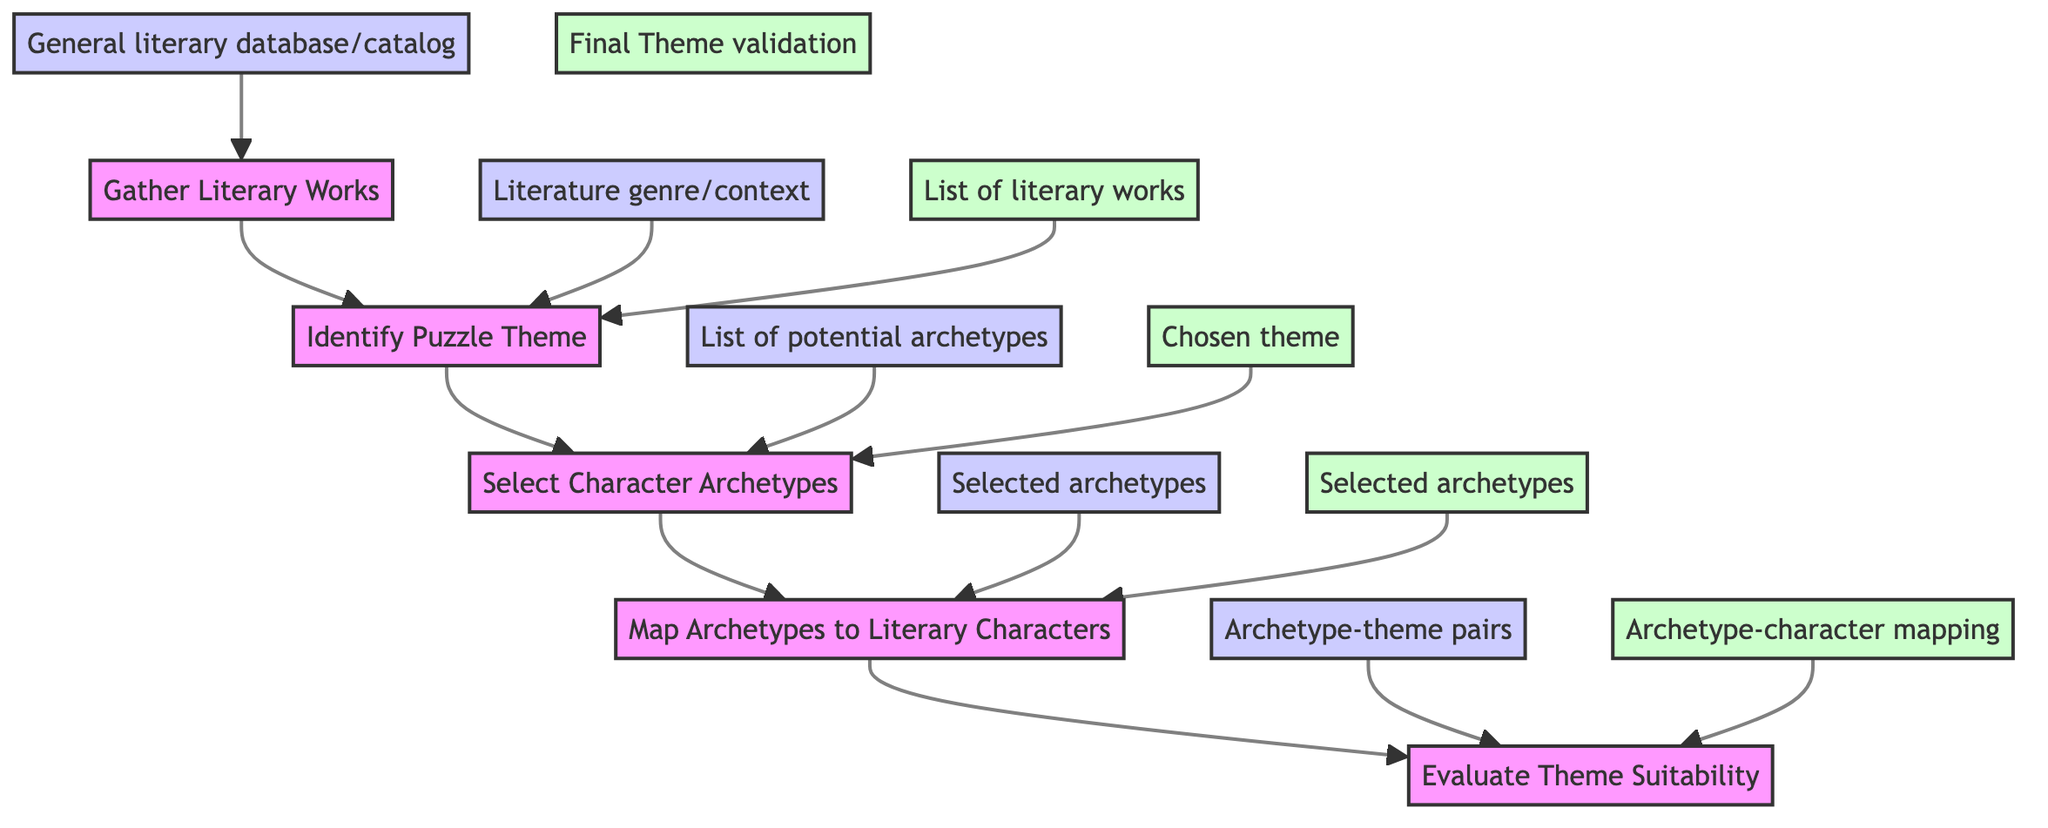What is the first step in the flowchart? The first step in the flowchart is to "Gather Literary Works," which is represented as node A. This is where diverse literary works are collected for analysis.
Answer: Gather Literary Works What is the output of the "Evaluate Theme Suitability" step? The output of the "Evaluate Theme Suitability" step, which is the final step E, is "Final Theme validation." This indicates that after assessing the archetypes' fit, the theme is validated.
Answer: Final Theme validation How many nodes are there in the flowchart? There are five nodes in the flowchart: "Gather Literary Works," "Identify Puzzle Theme," "Select Character Archetypes," "Map Archetypes to Literary Characters," and "Evaluate Theme Suitability." This includes both input and output nodes.
Answer: Five What input is needed for "Map Archetypes to Literary Characters"? The input needed for "Map Archetypes to Literary Characters," which is node D, is "Selected archetypes." These are the archetypes that have been chosen from earlier steps.
Answer: Selected archetypes Which step comes after "Select Character Archetypes"? The step that comes after "Select Character Archetypes," which is node C, is "Map Archetypes to Literary Characters," represented as node D. This indicates a sequential flow to identify characters corresponding to the archetypes.
Answer: Map Archetypes to Literary Characters What is the relationship between "Gather Literary Works" and "Identify Puzzle Theme"? The relationship between "Gather Literary Works" and "Identify Puzzle Theme" is that the output of "Gather Literary Works" serves as the input for "Identify Puzzle Theme." This means the collected works help define the puzzle theme.
Answer: Output serves as input What is the input for "Evaluate Theme Suitability"? The input for "Evaluate Theme Suitability," which is node E, is "Archetype-theme pairs." This indicates the specific data processed to validate the theme's appropriateness.
Answer: Archetype-theme pairs What type of data serves as an input for the "Gather Literary Works" step? The "Gather Literary Works" step requires input from a "General literary database/catalog," which indicates the source of literary works used for analysis in the flowchart.
Answer: General literary database/catalog Which node is the last in the workflow? The last node in the workflow is "Evaluate Theme Suitability," which is node E. It marks the conclusion of the process where the suitability of the theme is validated based on the analysis performed earlier.
Answer: Evaluate Theme Suitability 